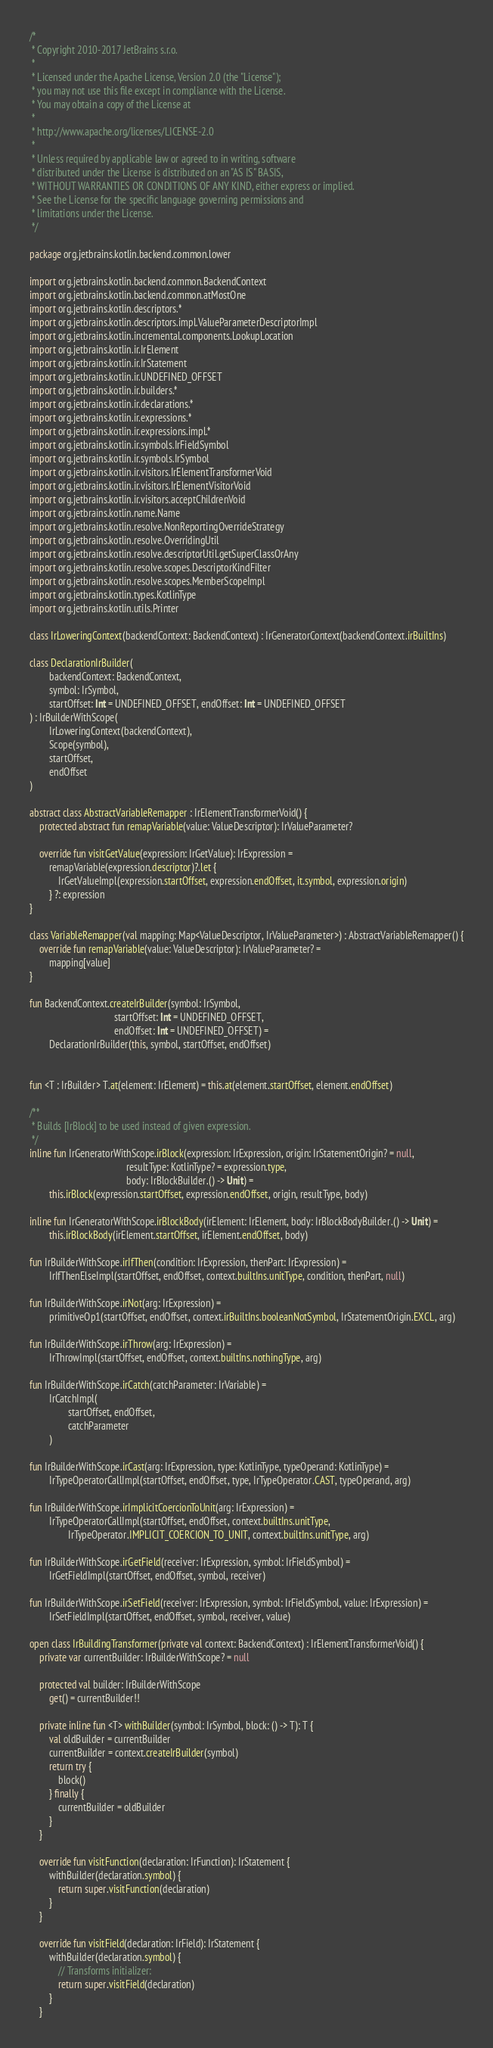Convert code to text. <code><loc_0><loc_0><loc_500><loc_500><_Kotlin_>/*
 * Copyright 2010-2017 JetBrains s.r.o.
 *
 * Licensed under the Apache License, Version 2.0 (the "License");
 * you may not use this file except in compliance with the License.
 * You may obtain a copy of the License at
 *
 * http://www.apache.org/licenses/LICENSE-2.0
 *
 * Unless required by applicable law or agreed to in writing, software
 * distributed under the License is distributed on an "AS IS" BASIS,
 * WITHOUT WARRANTIES OR CONDITIONS OF ANY KIND, either express or implied.
 * See the License for the specific language governing permissions and
 * limitations under the License.
 */

package org.jetbrains.kotlin.backend.common.lower

import org.jetbrains.kotlin.backend.common.BackendContext
import org.jetbrains.kotlin.backend.common.atMostOne
import org.jetbrains.kotlin.descriptors.*
import org.jetbrains.kotlin.descriptors.impl.ValueParameterDescriptorImpl
import org.jetbrains.kotlin.incremental.components.LookupLocation
import org.jetbrains.kotlin.ir.IrElement
import org.jetbrains.kotlin.ir.IrStatement
import org.jetbrains.kotlin.ir.UNDEFINED_OFFSET
import org.jetbrains.kotlin.ir.builders.*
import org.jetbrains.kotlin.ir.declarations.*
import org.jetbrains.kotlin.ir.expressions.*
import org.jetbrains.kotlin.ir.expressions.impl.*
import org.jetbrains.kotlin.ir.symbols.IrFieldSymbol
import org.jetbrains.kotlin.ir.symbols.IrSymbol
import org.jetbrains.kotlin.ir.visitors.IrElementTransformerVoid
import org.jetbrains.kotlin.ir.visitors.IrElementVisitorVoid
import org.jetbrains.kotlin.ir.visitors.acceptChildrenVoid
import org.jetbrains.kotlin.name.Name
import org.jetbrains.kotlin.resolve.NonReportingOverrideStrategy
import org.jetbrains.kotlin.resolve.OverridingUtil
import org.jetbrains.kotlin.resolve.descriptorUtil.getSuperClassOrAny
import org.jetbrains.kotlin.resolve.scopes.DescriptorKindFilter
import org.jetbrains.kotlin.resolve.scopes.MemberScopeImpl
import org.jetbrains.kotlin.types.KotlinType
import org.jetbrains.kotlin.utils.Printer

class IrLoweringContext(backendContext: BackendContext) : IrGeneratorContext(backendContext.irBuiltIns)

class DeclarationIrBuilder(
        backendContext: BackendContext,
        symbol: IrSymbol,
        startOffset: Int = UNDEFINED_OFFSET, endOffset: Int = UNDEFINED_OFFSET
) : IrBuilderWithScope(
        IrLoweringContext(backendContext),
        Scope(symbol),
        startOffset,
        endOffset
)

abstract class AbstractVariableRemapper : IrElementTransformerVoid() {
    protected abstract fun remapVariable(value: ValueDescriptor): IrValueParameter?

    override fun visitGetValue(expression: IrGetValue): IrExpression =
        remapVariable(expression.descriptor)?.let {
            IrGetValueImpl(expression.startOffset, expression.endOffset, it.symbol, expression.origin)
        } ?: expression
}

class VariableRemapper(val mapping: Map<ValueDescriptor, IrValueParameter>) : AbstractVariableRemapper() {
    override fun remapVariable(value: ValueDescriptor): IrValueParameter? =
        mapping[value]
}

fun BackendContext.createIrBuilder(symbol: IrSymbol,
                                   startOffset: Int = UNDEFINED_OFFSET,
                                   endOffset: Int = UNDEFINED_OFFSET) =
        DeclarationIrBuilder(this, symbol, startOffset, endOffset)


fun <T : IrBuilder> T.at(element: IrElement) = this.at(element.startOffset, element.endOffset)

/**
 * Builds [IrBlock] to be used instead of given expression.
 */
inline fun IrGeneratorWithScope.irBlock(expression: IrExpression, origin: IrStatementOrigin? = null,
                                        resultType: KotlinType? = expression.type,
                                        body: IrBlockBuilder.() -> Unit) =
        this.irBlock(expression.startOffset, expression.endOffset, origin, resultType, body)

inline fun IrGeneratorWithScope.irBlockBody(irElement: IrElement, body: IrBlockBodyBuilder.() -> Unit) =
        this.irBlockBody(irElement.startOffset, irElement.endOffset, body)

fun IrBuilderWithScope.irIfThen(condition: IrExpression, thenPart: IrExpression) =
        IrIfThenElseImpl(startOffset, endOffset, context.builtIns.unitType, condition, thenPart, null)

fun IrBuilderWithScope.irNot(arg: IrExpression) =
        primitiveOp1(startOffset, endOffset, context.irBuiltIns.booleanNotSymbol, IrStatementOrigin.EXCL, arg)

fun IrBuilderWithScope.irThrow(arg: IrExpression) =
        IrThrowImpl(startOffset, endOffset, context.builtIns.nothingType, arg)

fun IrBuilderWithScope.irCatch(catchParameter: IrVariable) =
        IrCatchImpl(
                startOffset, endOffset,
                catchParameter
        )

fun IrBuilderWithScope.irCast(arg: IrExpression, type: KotlinType, typeOperand: KotlinType) =
        IrTypeOperatorCallImpl(startOffset, endOffset, type, IrTypeOperator.CAST, typeOperand, arg)

fun IrBuilderWithScope.irImplicitCoercionToUnit(arg: IrExpression) =
        IrTypeOperatorCallImpl(startOffset, endOffset, context.builtIns.unitType,
                IrTypeOperator.IMPLICIT_COERCION_TO_UNIT, context.builtIns.unitType, arg)

fun IrBuilderWithScope.irGetField(receiver: IrExpression, symbol: IrFieldSymbol) =
        IrGetFieldImpl(startOffset, endOffset, symbol, receiver)

fun IrBuilderWithScope.irSetField(receiver: IrExpression, symbol: IrFieldSymbol, value: IrExpression) =
        IrSetFieldImpl(startOffset, endOffset, symbol, receiver, value)

open class IrBuildingTransformer(private val context: BackendContext) : IrElementTransformerVoid() {
    private var currentBuilder: IrBuilderWithScope? = null

    protected val builder: IrBuilderWithScope
        get() = currentBuilder!!

    private inline fun <T> withBuilder(symbol: IrSymbol, block: () -> T): T {
        val oldBuilder = currentBuilder
        currentBuilder = context.createIrBuilder(symbol)
        return try {
            block()
        } finally {
            currentBuilder = oldBuilder
        }
    }

    override fun visitFunction(declaration: IrFunction): IrStatement {
        withBuilder(declaration.symbol) {
            return super.visitFunction(declaration)
        }
    }

    override fun visitField(declaration: IrField): IrStatement {
        withBuilder(declaration.symbol) {
            // Transforms initializer:
            return super.visitField(declaration)
        }
    }
</code> 